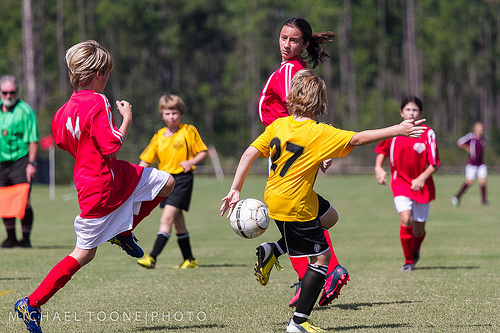<image>
Is there a jersey on the girl? No. The jersey is not positioned on the girl. They may be near each other, but the jersey is not supported by or resting on top of the girl. Is there a ball above the grass? Yes. The ball is positioned above the grass in the vertical space, higher up in the scene. 